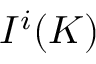Convert formula to latex. <formula><loc_0><loc_0><loc_500><loc_500>I ^ { i } ( K )</formula> 